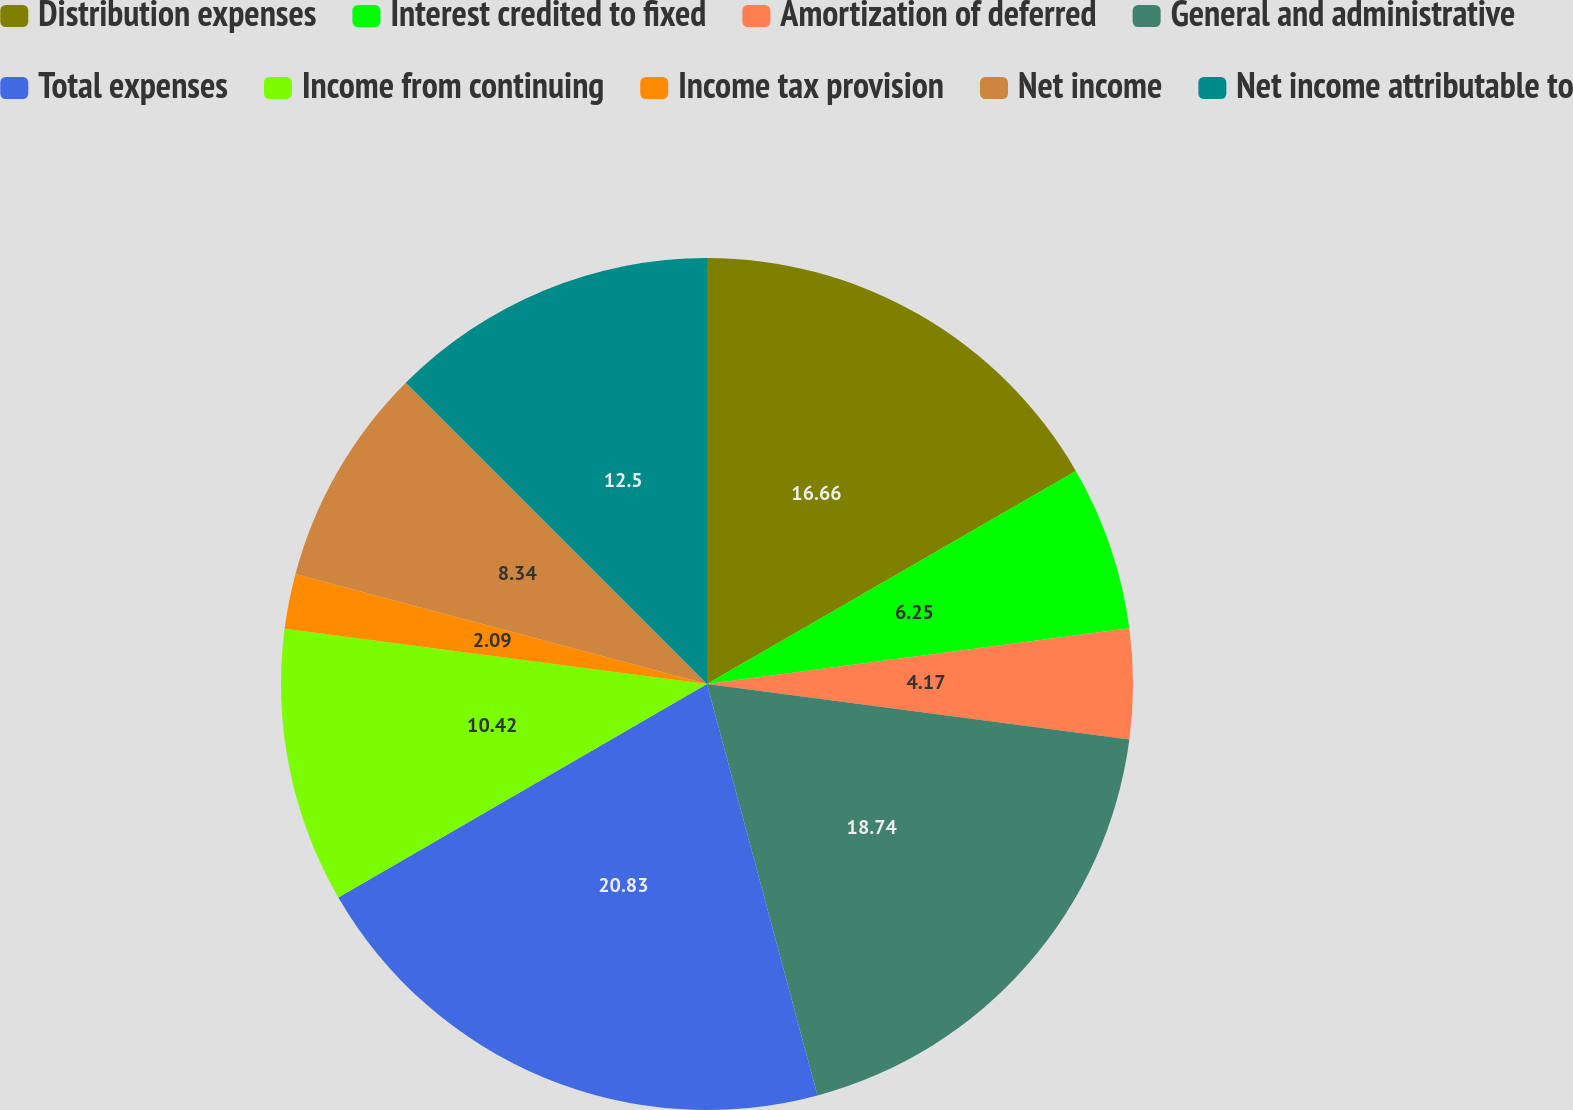Convert chart to OTSL. <chart><loc_0><loc_0><loc_500><loc_500><pie_chart><fcel>Distribution expenses<fcel>Interest credited to fixed<fcel>Amortization of deferred<fcel>General and administrative<fcel>Total expenses<fcel>Income from continuing<fcel>Income tax provision<fcel>Net income<fcel>Net income attributable to<nl><fcel>16.66%<fcel>6.25%<fcel>4.17%<fcel>18.74%<fcel>20.82%<fcel>10.42%<fcel>2.09%<fcel>8.34%<fcel>12.5%<nl></chart> 